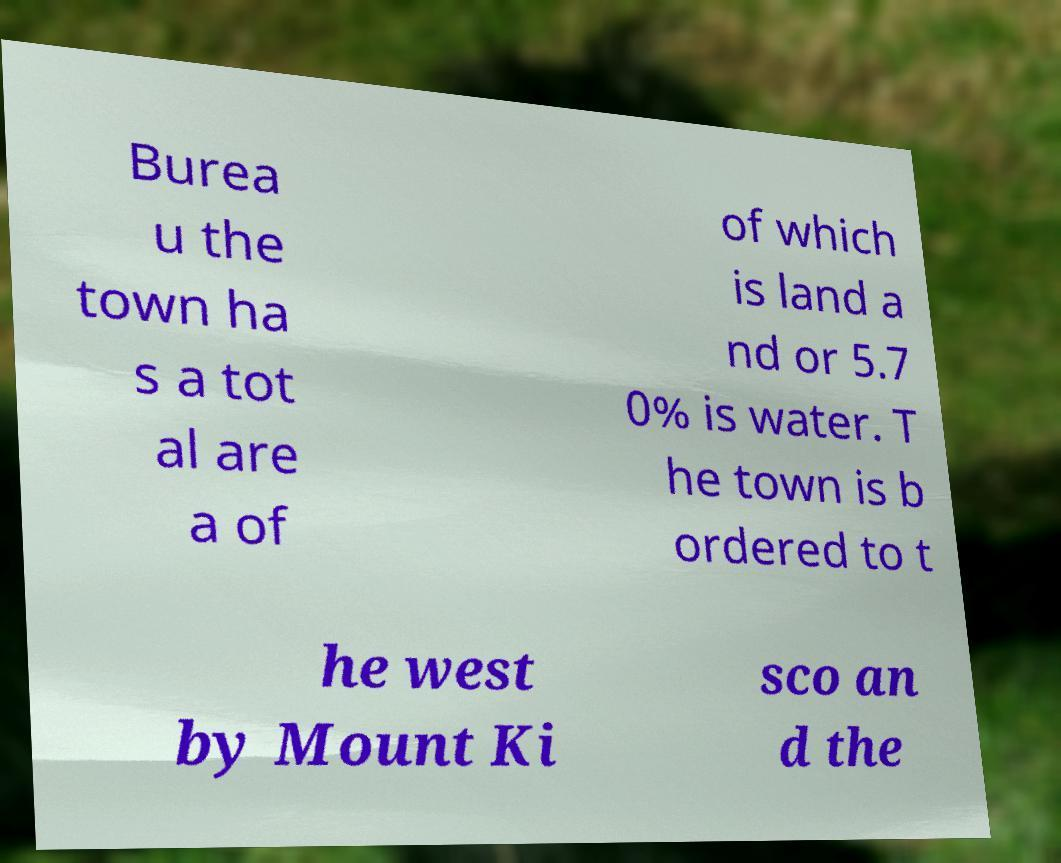Could you assist in decoding the text presented in this image and type it out clearly? Burea u the town ha s a tot al are a of of which is land a nd or 5.7 0% is water. T he town is b ordered to t he west by Mount Ki sco an d the 